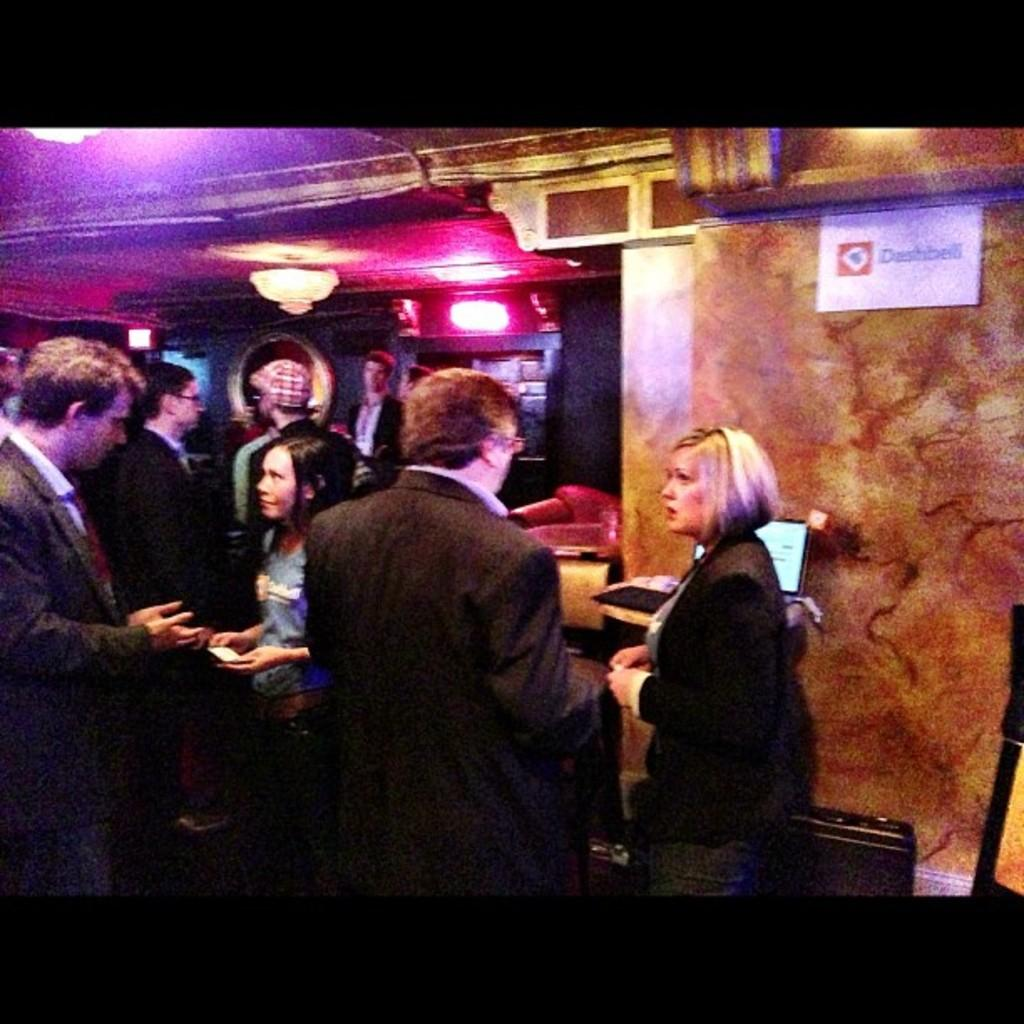How many people are in the image? There is a group of people standing in the image. What is on the wall in the image? There is a paper on the wall in the image. What type of lighting fixture is present in the image? There is a chandelier in the image. Can you describe any objects present in the image? There are objects present in the image, but their specific details are not mentioned in the provided facts. What type of treatment is being offered at the shop in the image? There is no shop or treatment mentioned in the image; it features a group of people, a paper on the wall, and a chandelier. 